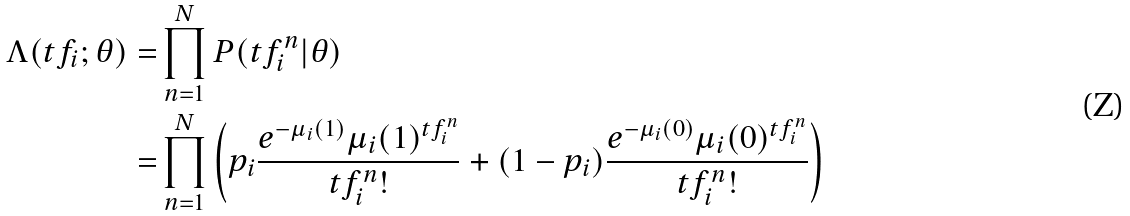<formula> <loc_0><loc_0><loc_500><loc_500>\Lambda ( t f _ { i } ; \theta ) = & \prod _ { n = 1 } ^ { N } P ( t f _ { i } ^ { n } | \theta ) \\ = & \prod _ { n = 1 } ^ { N } \left ( p _ { i } \frac { e ^ { - \mu _ { i } ( 1 ) } \mu _ { i } ( 1 ) ^ { t f _ { i } ^ { n } } } { t f _ { i } ^ { n } ! } + ( 1 - p _ { i } ) \frac { e ^ { - \mu _ { i } ( 0 ) } \mu _ { i } ( 0 ) ^ { t f _ { i } ^ { n } } } { t f _ { i } ^ { n } ! } \right )</formula> 